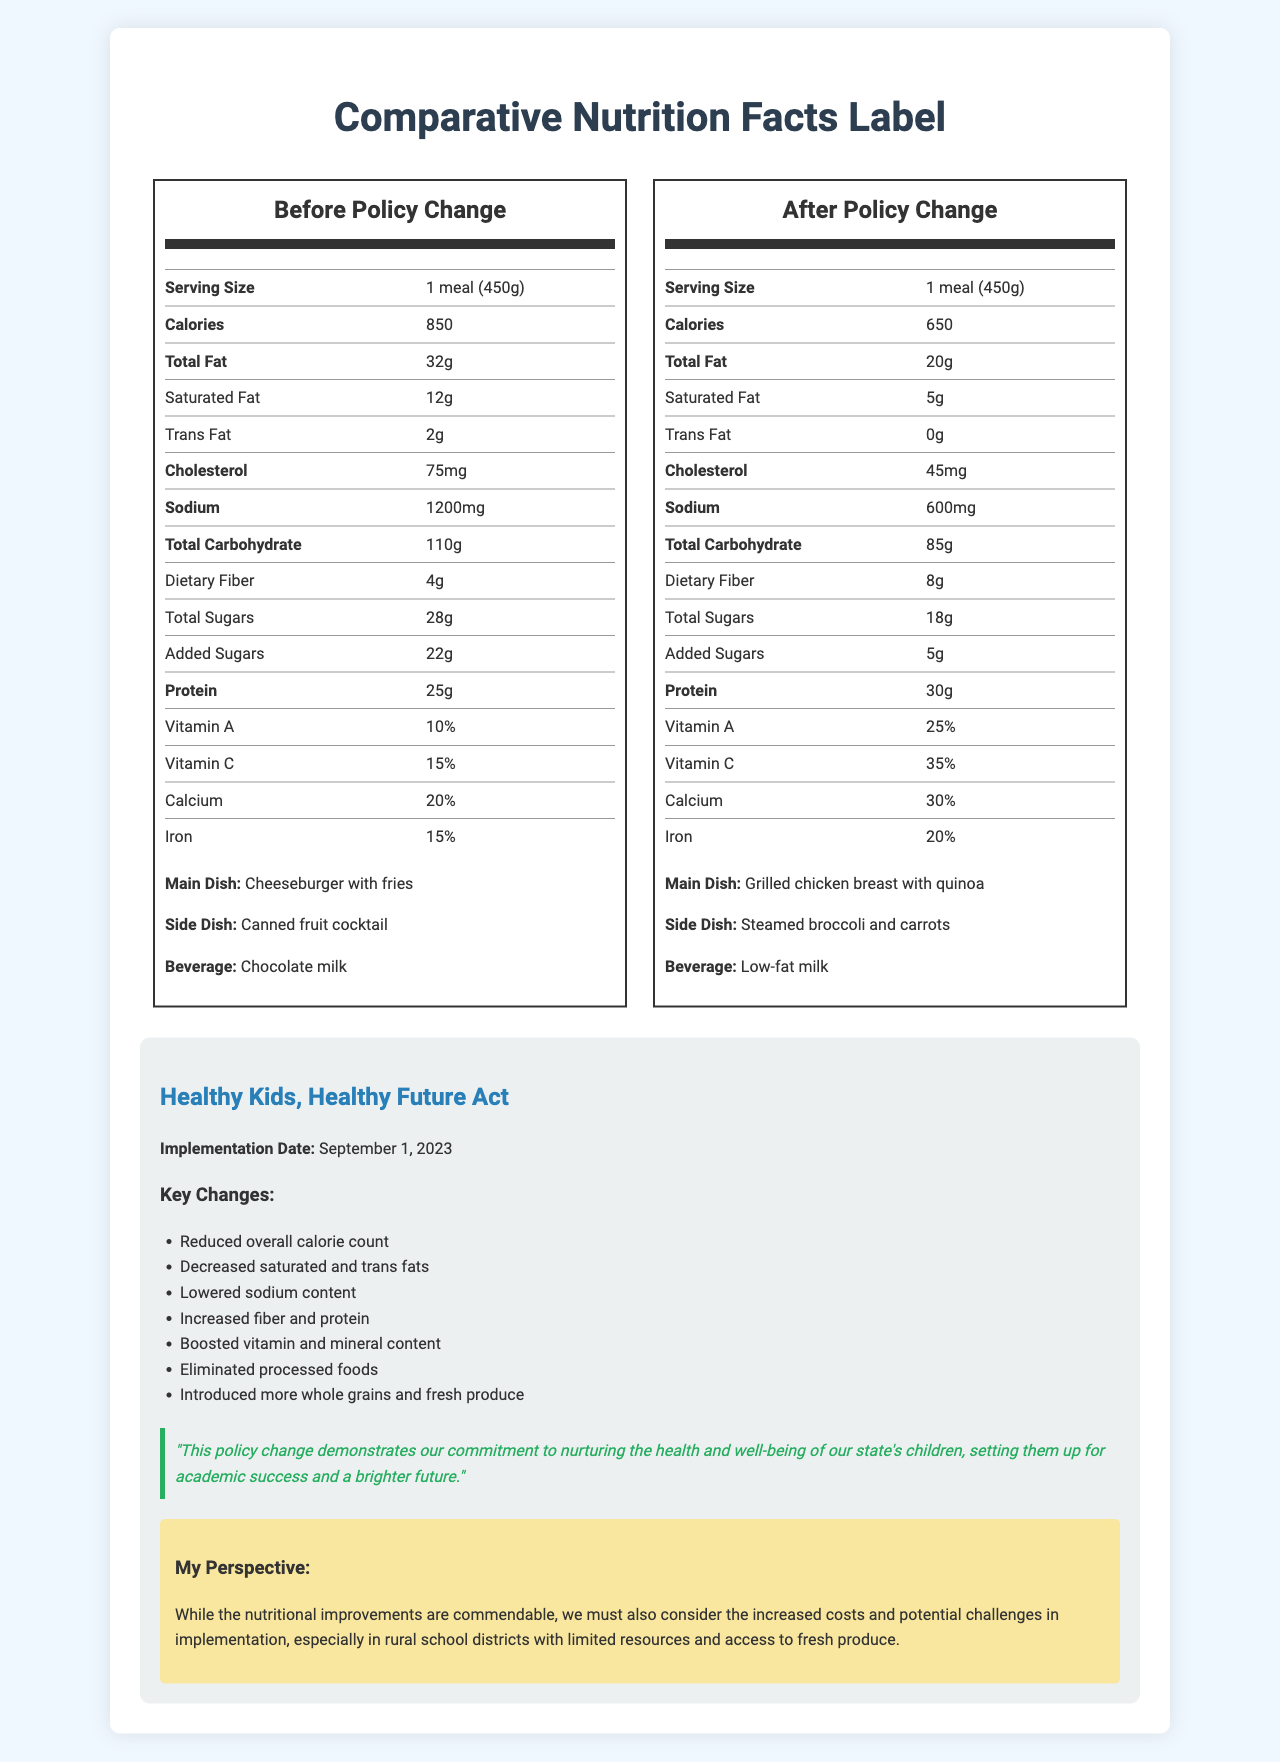what is the serving size of the meals both before and after the policy change? The document states that the serving size for both before and after the policy change is "1 meal (450g)".
Answer: 1 meal (450g) how many calories are in the meal after the policy change? The document specifies that the calorie count after the policy change is 650.
Answer: 650 how much total fat is in the meal before the policy change? The total fat content before the policy change is listed as 32 grams.
Answer: 32g what is the main dish after the policy change? The document mentions that the main dish after the policy change is "Grilled chicken breast with quinoa".
Answer: Grilled chicken breast with quinoa what is the sodium content in the meal before the policy change? The sodium content before the policy change is 1200 milligrams.
Answer: 1200mg which meal has more protein, before or after the policy change? The meal after the policy change has 30 grams of protein, compared to 25 grams before the policy change.
Answer: After what beverage is provided after the policy change? The beverage after the policy change is "Low-fat milk".
Answer: Low-fat milk what side dish is provided before the policy change? A. Steamed broccoli and carrots B. Canned fruit cocktail C. Fresh fruit D. Mixed greens salad The side dish before the policy change is "Canned fruit cocktail".
Answer: B which nutrient saw an increase in percentage from before to after the policy change? A. Vitamin A B. Iron C. Total Sugars D. Sodium Vitamin A increased from 10% before the policy change to 25% after the policy change.
Answer: A is there any trans fat in the meal after the policy change? The document states that the trans fat content after the policy change is 0 grams.
Answer: No summarize the comparison of nutritional values before and after the policy change. The document showcases the improvements in nutritional content and food quality following the policy change, highlighting better health benefits for students.
Answer: The document compares the nutritional values of school lunches before and after the implementation of the "Healthy Kids, Healthy Future Act." After the policy change, the meals have significantly fewer calories, fat (especially saturated and trans fats), cholesterol, sodium, total sugars, and added sugars, while dietary fiber, protein, vitamins, and minerals like vitamin A, vitamin C, calcium, and iron have increased. The food options also shifted from processed foods to healthier options such as grilled chicken and fresh produce. can you determine the cost increase for implementing the new policy based on the document? The document does not provide any information regarding the cost implications of implementing the new policy.
Answer: Cannot be determined 